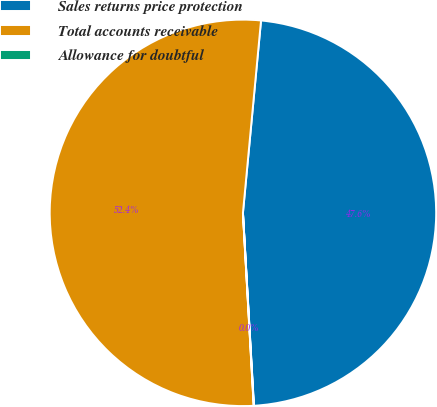Convert chart. <chart><loc_0><loc_0><loc_500><loc_500><pie_chart><fcel>Sales returns price protection<fcel>Total accounts receivable<fcel>Allowance for doubtful<nl><fcel>47.6%<fcel>52.38%<fcel>0.02%<nl></chart> 